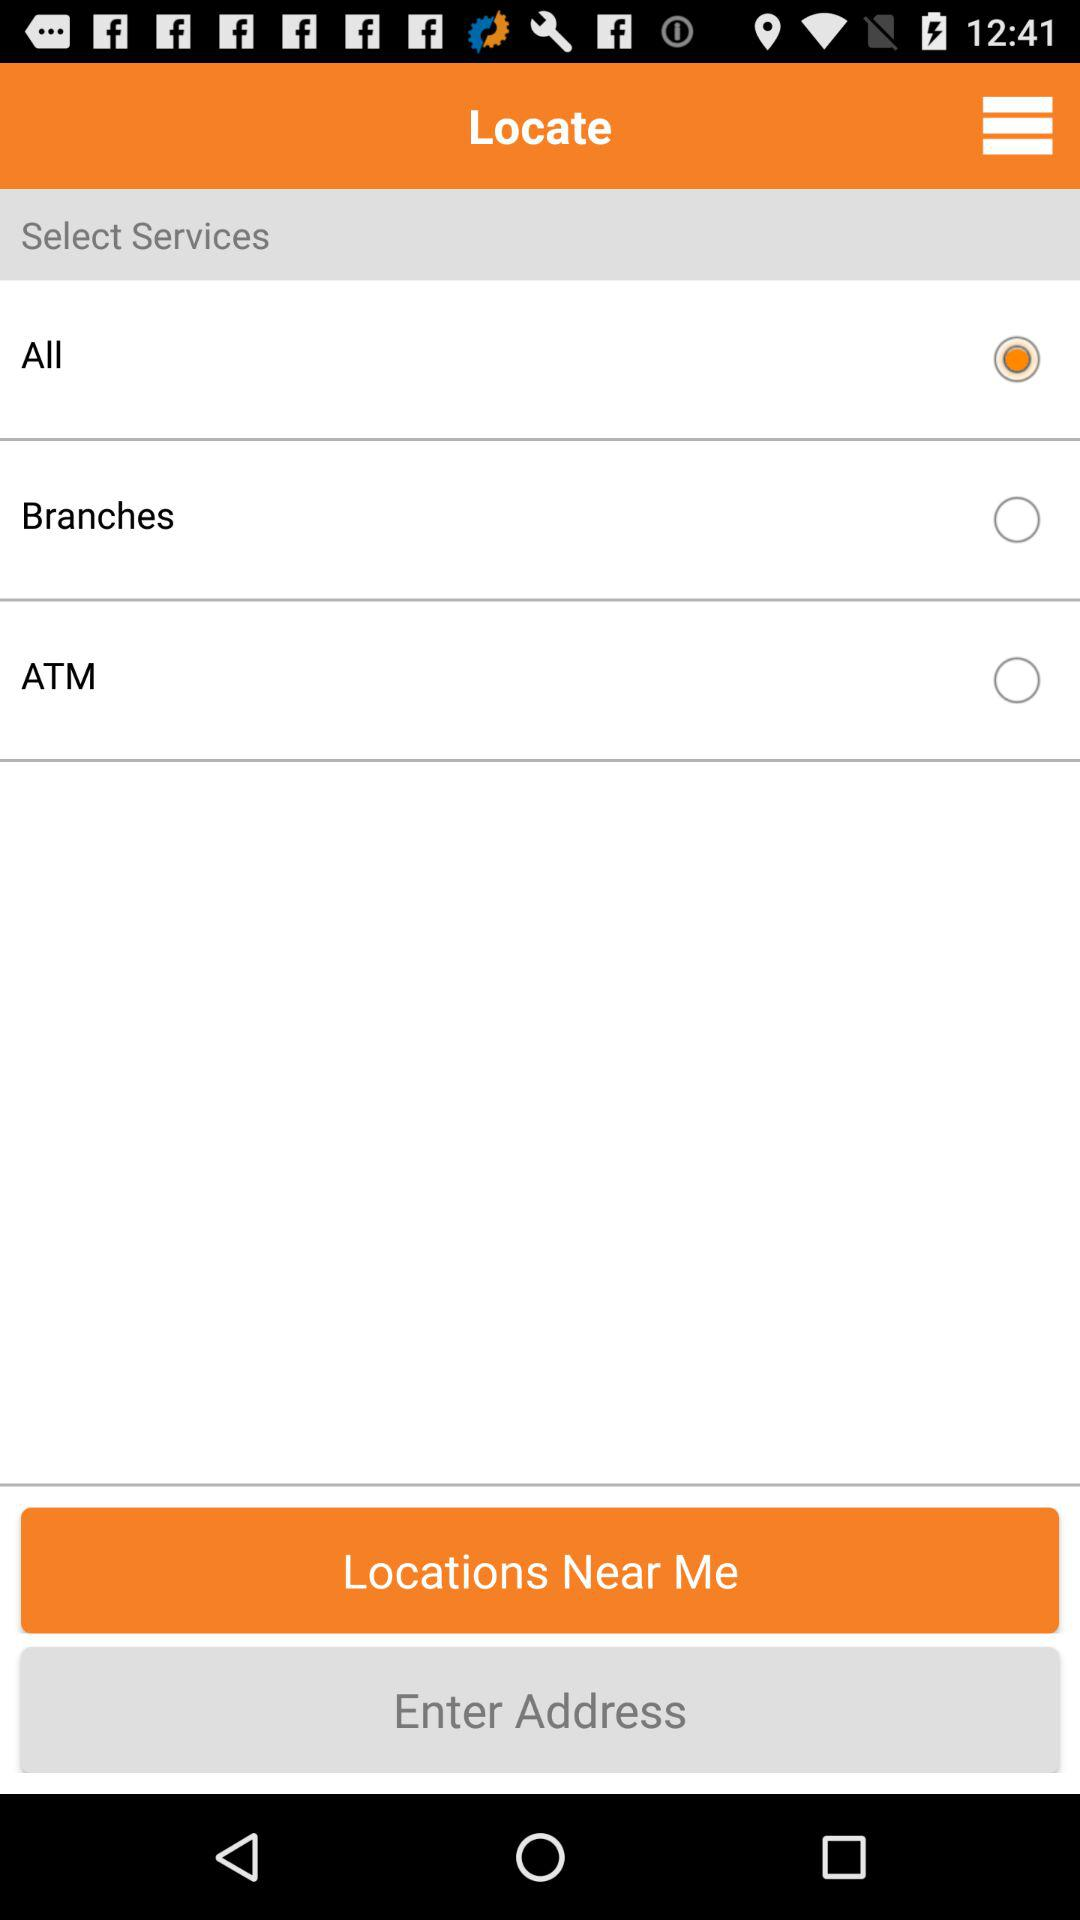What are the available options? The available options are "All", "Branches" and "ATM". 